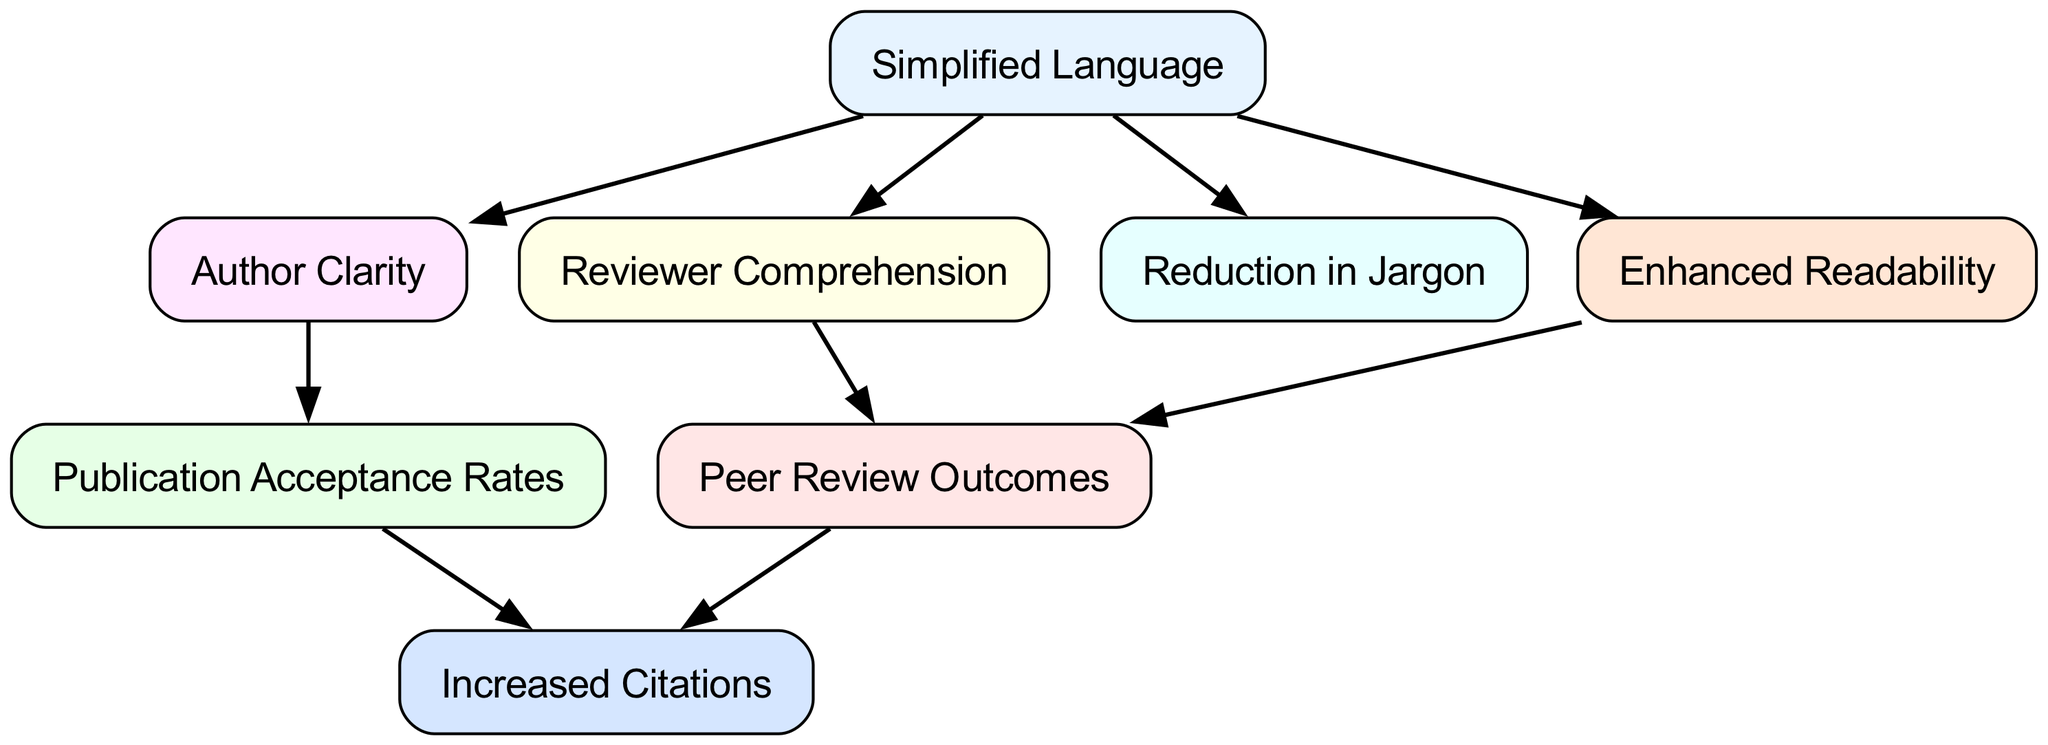What is the total number of nodes in the diagram? The diagram contains a total of eight nodes as seen in the nodes list: Simplified Language, Peer Review Outcomes, Publication Acceptance Rates, Reviewer Comprehension, Author Clarity, Reduction in Jargon, Enhanced Readability, and Increased Citations.
Answer: 8 Which node directly influences Reviewer Comprehension? Simplified Language directly influences Reviewer Comprehension, as indicated by the edge connecting the two nodes in the diagram.
Answer: Simplified Language What are the two nodes that lead to Increased Citations? The nodes that influence Increased Citations are Peer Review Outcomes and Publication Acceptance Rates. Both nodes have a directed edge pointing to Increased Citations.
Answer: Peer Review Outcomes and Publication Acceptance Rates How many edges are present in the diagram? There are a total of eight edges in the diagram, as listed in the edges section connecting the various nodes.
Answer: 8 What is the influence relationship between Enhanced Readability and Peer Review Outcomes? Enhanced Readability has a direct influence on Peer Review Outcomes, as shown by the directed edge connecting them.
Answer: Enhanced Readability influences Peer Review Outcomes If Simplified Language is adopted, what effect does it have on Author Clarity? Adopting Simplified Language leads to improved Author Clarity, as indicated by the direct edge from Simplified Language to Author Clarity.
Answer: Improvement Which node does not have any outgoing edges? Increased Citations does not have any outgoing edges, as it receives influences from Peer Review Outcomes and Publication Acceptance Rates but does not influence any other nodes.
Answer: Increased Citations How does Reduction in Jargon connect to other nodes? Reduction in Jargon is influenced by Simplified Language but does not appear to have direct outgoing influences to other nodes in the diagram.
Answer: One incoming influence What is the pathway from Simplified Language to Increased Citations? The pathway from Simplified Language to Increased Citations involves passing through several nodes: Simplified Language influences Reviewer Comprehension and Author Clarity, which in turn connect to Peer Review Outcomes and Publication Acceptance Rates. Both of these nodes then lead to Increased Citations.
Answer: Simplified Language → Reviewer Comprehension → Peer Review Outcomes → Increased Citations and Simplified Language → Author Clarity → Publication Acceptance Rates → Increased Citations 